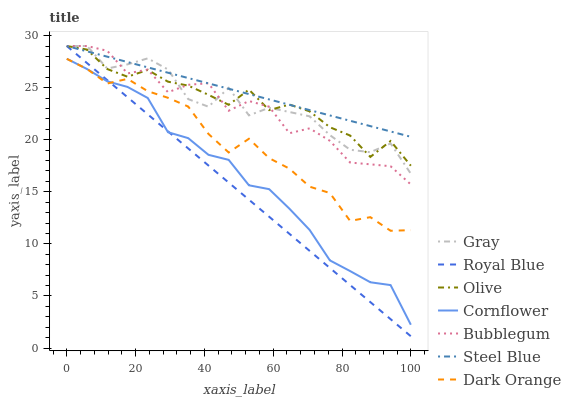Does Royal Blue have the minimum area under the curve?
Answer yes or no. Yes. Does Steel Blue have the maximum area under the curve?
Answer yes or no. Yes. Does Cornflower have the minimum area under the curve?
Answer yes or no. No. Does Cornflower have the maximum area under the curve?
Answer yes or no. No. Is Steel Blue the smoothest?
Answer yes or no. Yes. Is Gray the roughest?
Answer yes or no. Yes. Is Cornflower the smoothest?
Answer yes or no. No. Is Cornflower the roughest?
Answer yes or no. No. Does Royal Blue have the lowest value?
Answer yes or no. Yes. Does Cornflower have the lowest value?
Answer yes or no. No. Does Olive have the highest value?
Answer yes or no. Yes. Does Cornflower have the highest value?
Answer yes or no. No. Is Cornflower less than Gray?
Answer yes or no. Yes. Is Bubblegum greater than Dark Orange?
Answer yes or no. Yes. Does Olive intersect Royal Blue?
Answer yes or no. Yes. Is Olive less than Royal Blue?
Answer yes or no. No. Is Olive greater than Royal Blue?
Answer yes or no. No. Does Cornflower intersect Gray?
Answer yes or no. No. 